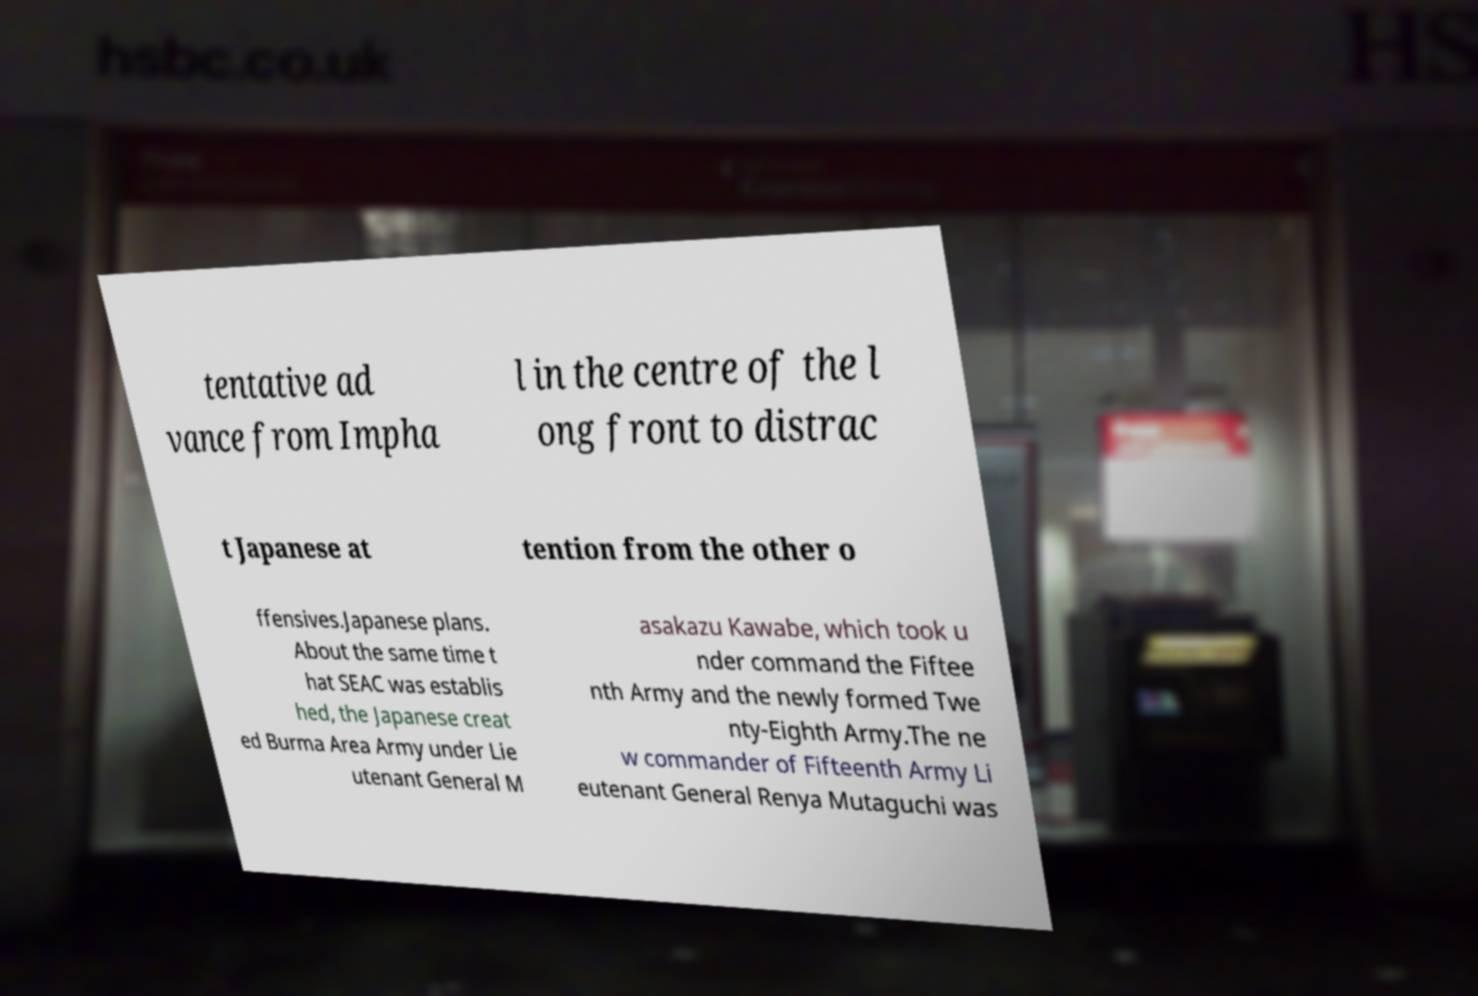Could you assist in decoding the text presented in this image and type it out clearly? tentative ad vance from Impha l in the centre of the l ong front to distrac t Japanese at tention from the other o ffensives.Japanese plans. About the same time t hat SEAC was establis hed, the Japanese creat ed Burma Area Army under Lie utenant General M asakazu Kawabe, which took u nder command the Fiftee nth Army and the newly formed Twe nty-Eighth Army.The ne w commander of Fifteenth Army Li eutenant General Renya Mutaguchi was 